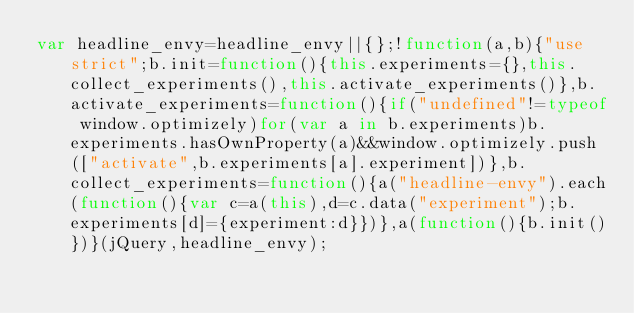Convert code to text. <code><loc_0><loc_0><loc_500><loc_500><_JavaScript_>var headline_envy=headline_envy||{};!function(a,b){"use strict";b.init=function(){this.experiments={},this.collect_experiments(),this.activate_experiments()},b.activate_experiments=function(){if("undefined"!=typeof window.optimizely)for(var a in b.experiments)b.experiments.hasOwnProperty(a)&&window.optimizely.push(["activate",b.experiments[a].experiment])},b.collect_experiments=function(){a("headline-envy").each(function(){var c=a(this),d=c.data("experiment");b.experiments[d]={experiment:d}})},a(function(){b.init()})}(jQuery,headline_envy);
</code> 